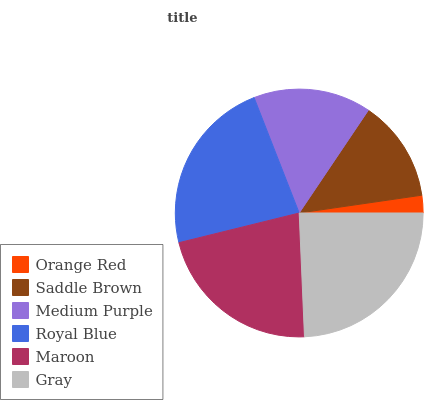Is Orange Red the minimum?
Answer yes or no. Yes. Is Gray the maximum?
Answer yes or no. Yes. Is Saddle Brown the minimum?
Answer yes or no. No. Is Saddle Brown the maximum?
Answer yes or no. No. Is Saddle Brown greater than Orange Red?
Answer yes or no. Yes. Is Orange Red less than Saddle Brown?
Answer yes or no. Yes. Is Orange Red greater than Saddle Brown?
Answer yes or no. No. Is Saddle Brown less than Orange Red?
Answer yes or no. No. Is Maroon the high median?
Answer yes or no. Yes. Is Medium Purple the low median?
Answer yes or no. Yes. Is Gray the high median?
Answer yes or no. No. Is Maroon the low median?
Answer yes or no. No. 